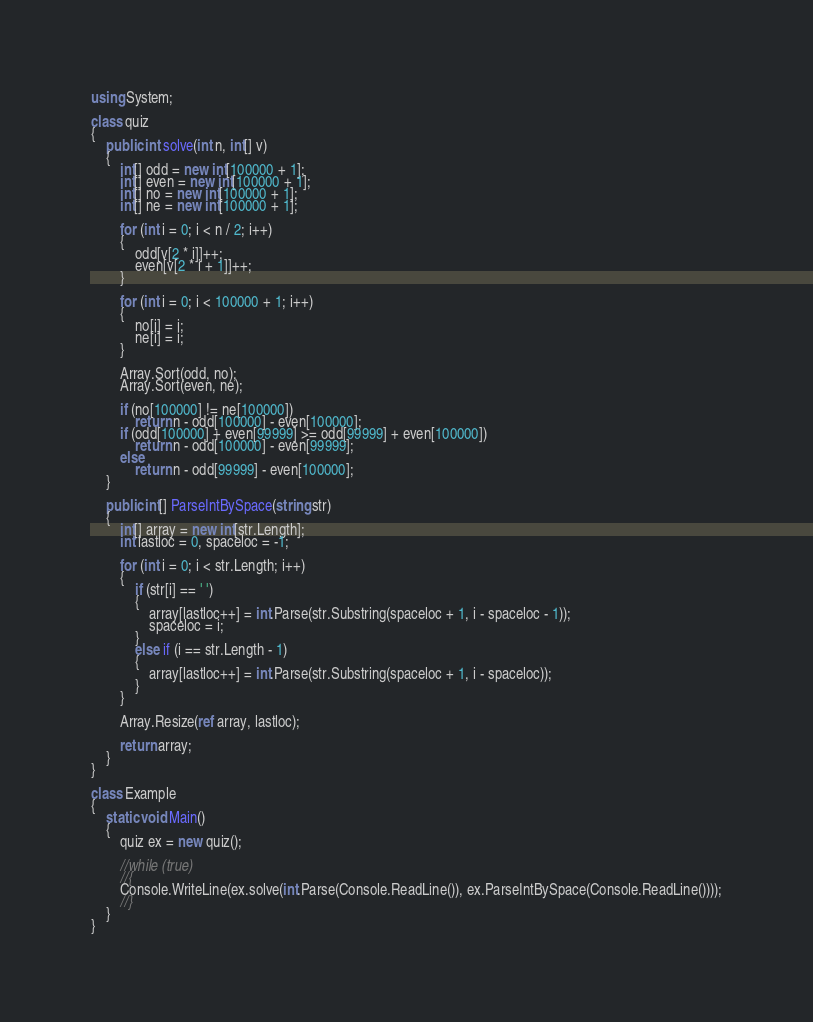<code> <loc_0><loc_0><loc_500><loc_500><_C#_>using System;

class quiz
{
    public int solve(int n, int[] v)
    {
        int[] odd = new int[100000 + 1];
        int[] even = new int[100000 + 1];
        int[] no = new int[100000 + 1];
        int[] ne = new int[100000 + 1];

        for (int i = 0; i < n / 2; i++)
        {
            odd[v[2 * i]]++;
            even[v[2 * i + 1]]++;
        }

        for (int i = 0; i < 100000 + 1; i++)
        {
            no[i] = i;
            ne[i] = i;
        }

        Array.Sort(odd, no);
        Array.Sort(even, ne);

        if (no[100000] != ne[100000])
            return n - odd[100000] - even[100000];
        if (odd[100000] + even[99999] >= odd[99999] + even[100000])
            return n - odd[100000] - even[99999];
        else
            return n - odd[99999] - even[100000];
    }

    public int[] ParseIntBySpace(string str)
    {
        int[] array = new int[str.Length];
        int lastloc = 0, spaceloc = -1;

        for (int i = 0; i < str.Length; i++)
        {
            if (str[i] == ' ')
            {
                array[lastloc++] = int.Parse(str.Substring(spaceloc + 1, i - spaceloc - 1));
                spaceloc = i;
            }
            else if (i == str.Length - 1)
            {
                array[lastloc++] = int.Parse(str.Substring(spaceloc + 1, i - spaceloc));
            }
        }

        Array.Resize(ref array, lastloc);

        return array;
    }
}

class Example
{
    static void Main()
    {
        quiz ex = new quiz();

        //while (true)
        //{
        Console.WriteLine(ex.solve(int.Parse(Console.ReadLine()), ex.ParseIntBySpace(Console.ReadLine())));
        //}
    }
}</code> 